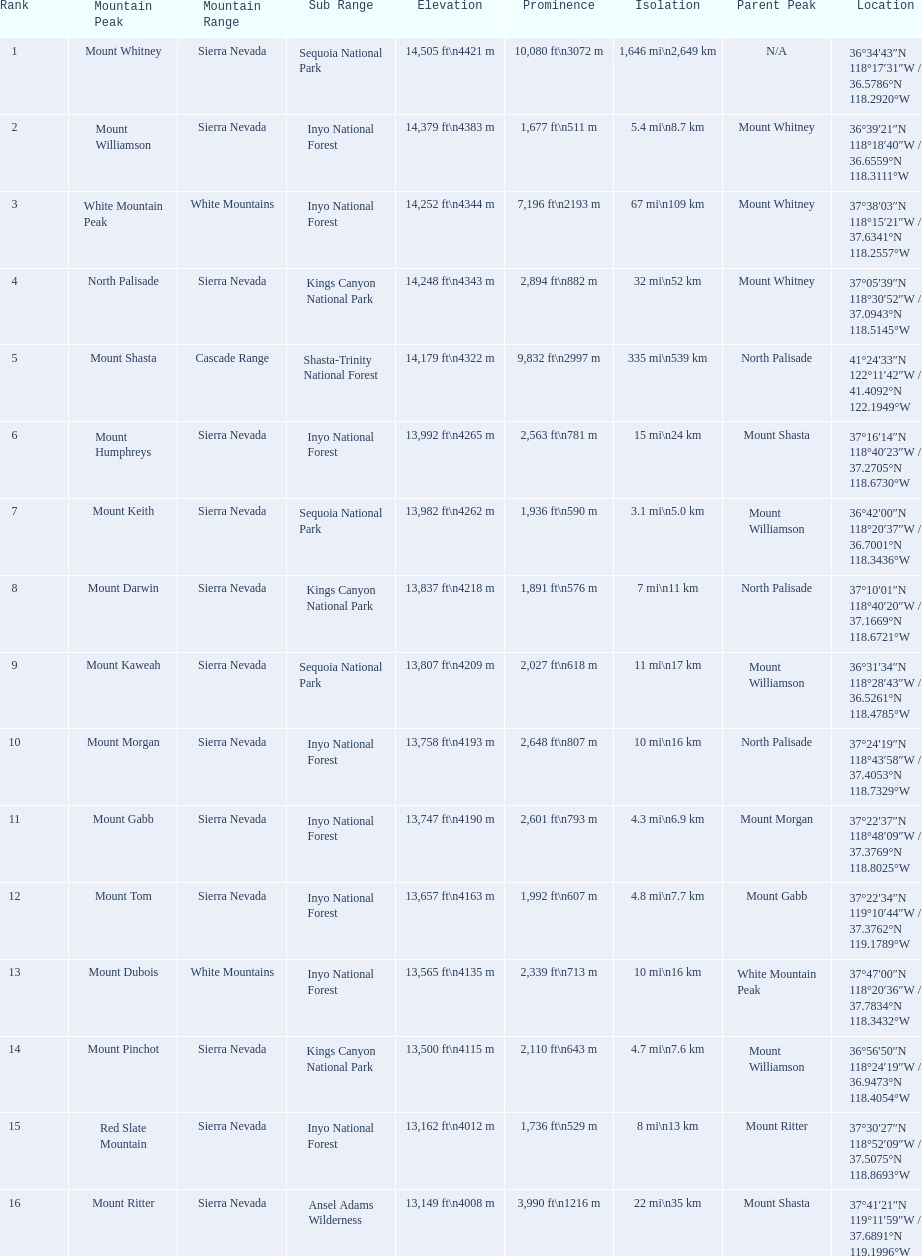What mountain peak is listed for the sierra nevada mountain range? Mount Whitney. What mountain peak has an elevation of 14,379ft? Mount Williamson. Which mountain is listed for the cascade range? Mount Shasta. What are all of the mountain peaks? Mount Whitney, Mount Williamson, White Mountain Peak, North Palisade, Mount Shasta, Mount Humphreys, Mount Keith, Mount Darwin, Mount Kaweah, Mount Morgan, Mount Gabb, Mount Tom, Mount Dubois, Mount Pinchot, Red Slate Mountain, Mount Ritter. In what ranges are they located? Sierra Nevada, Sierra Nevada, White Mountains, Sierra Nevada, Cascade Range, Sierra Nevada, Sierra Nevada, Sierra Nevada, Sierra Nevada, Sierra Nevada, Sierra Nevada, Sierra Nevada, White Mountains, Sierra Nevada, Sierra Nevada, Sierra Nevada. And which mountain peak is in the cascade range? Mount Shasta. 